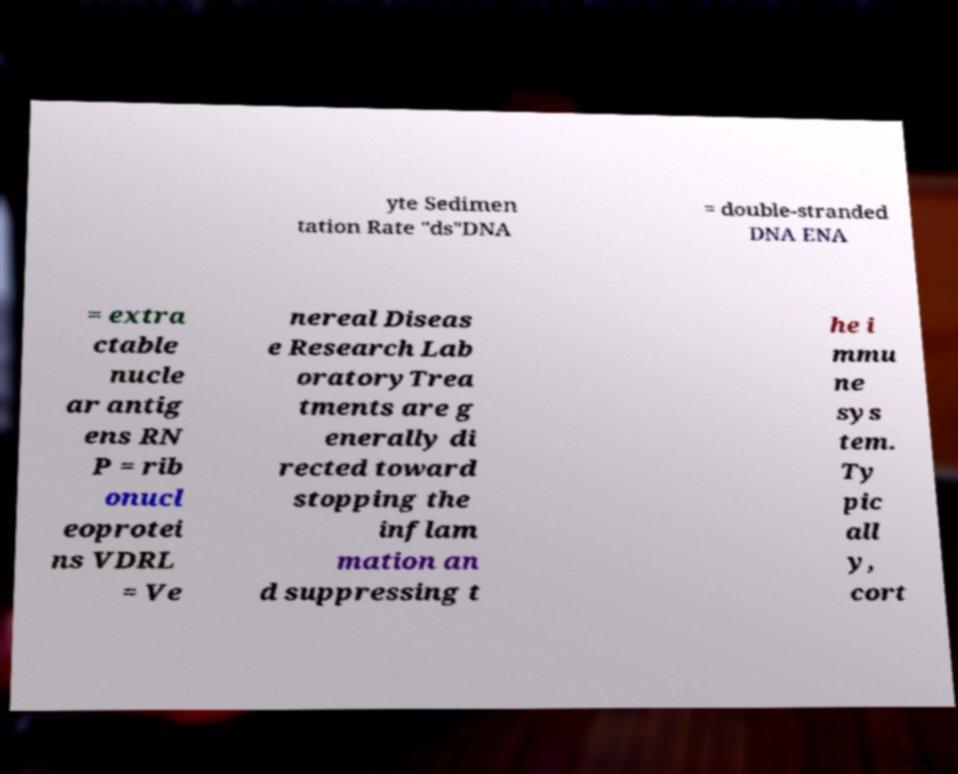Can you read and provide the text displayed in the image?This photo seems to have some interesting text. Can you extract and type it out for me? yte Sedimen tation Rate "ds"DNA = double-stranded DNA ENA = extra ctable nucle ar antig ens RN P = rib onucl eoprotei ns VDRL = Ve nereal Diseas e Research Lab oratoryTrea tments are g enerally di rected toward stopping the inflam mation an d suppressing t he i mmu ne sys tem. Ty pic all y, cort 